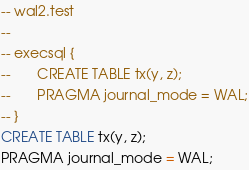<code> <loc_0><loc_0><loc_500><loc_500><_SQL_>-- wal2.test
-- 
-- execsql { 
--       CREATE TABLE tx(y, z);
--       PRAGMA journal_mode = WAL;
-- }
CREATE TABLE tx(y, z);
PRAGMA journal_mode = WAL;</code> 